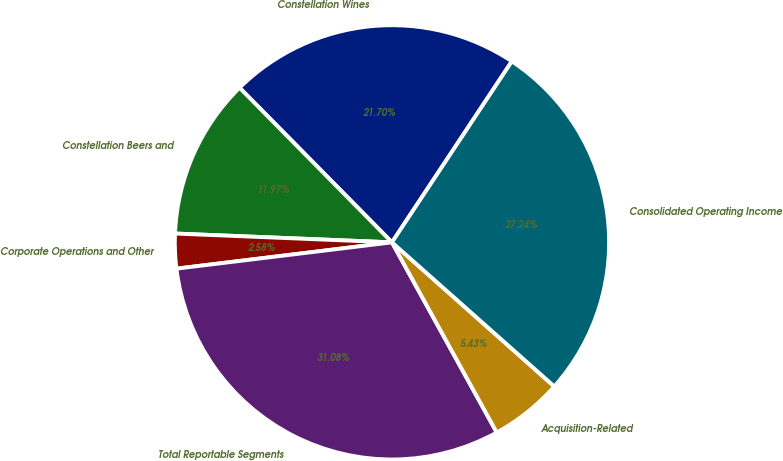<chart> <loc_0><loc_0><loc_500><loc_500><pie_chart><fcel>Constellation Wines<fcel>Constellation Beers and<fcel>Corporate Operations and Other<fcel>Total Reportable Segments<fcel>Acquisition-Related<fcel>Consolidated Operating Income<nl><fcel>21.7%<fcel>11.97%<fcel>2.58%<fcel>31.09%<fcel>5.43%<fcel>27.25%<nl></chart> 